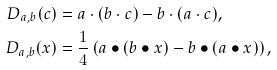<formula> <loc_0><loc_0><loc_500><loc_500>D _ { a , b } ( c ) & = a \cdot ( b \cdot c ) - b \cdot ( a \cdot c ) , \\ D _ { a , b } ( x ) & = \frac { 1 } { 4 } \left ( a \bullet ( b \bullet x ) - b \bullet ( a \bullet x ) \right ) ,</formula> 